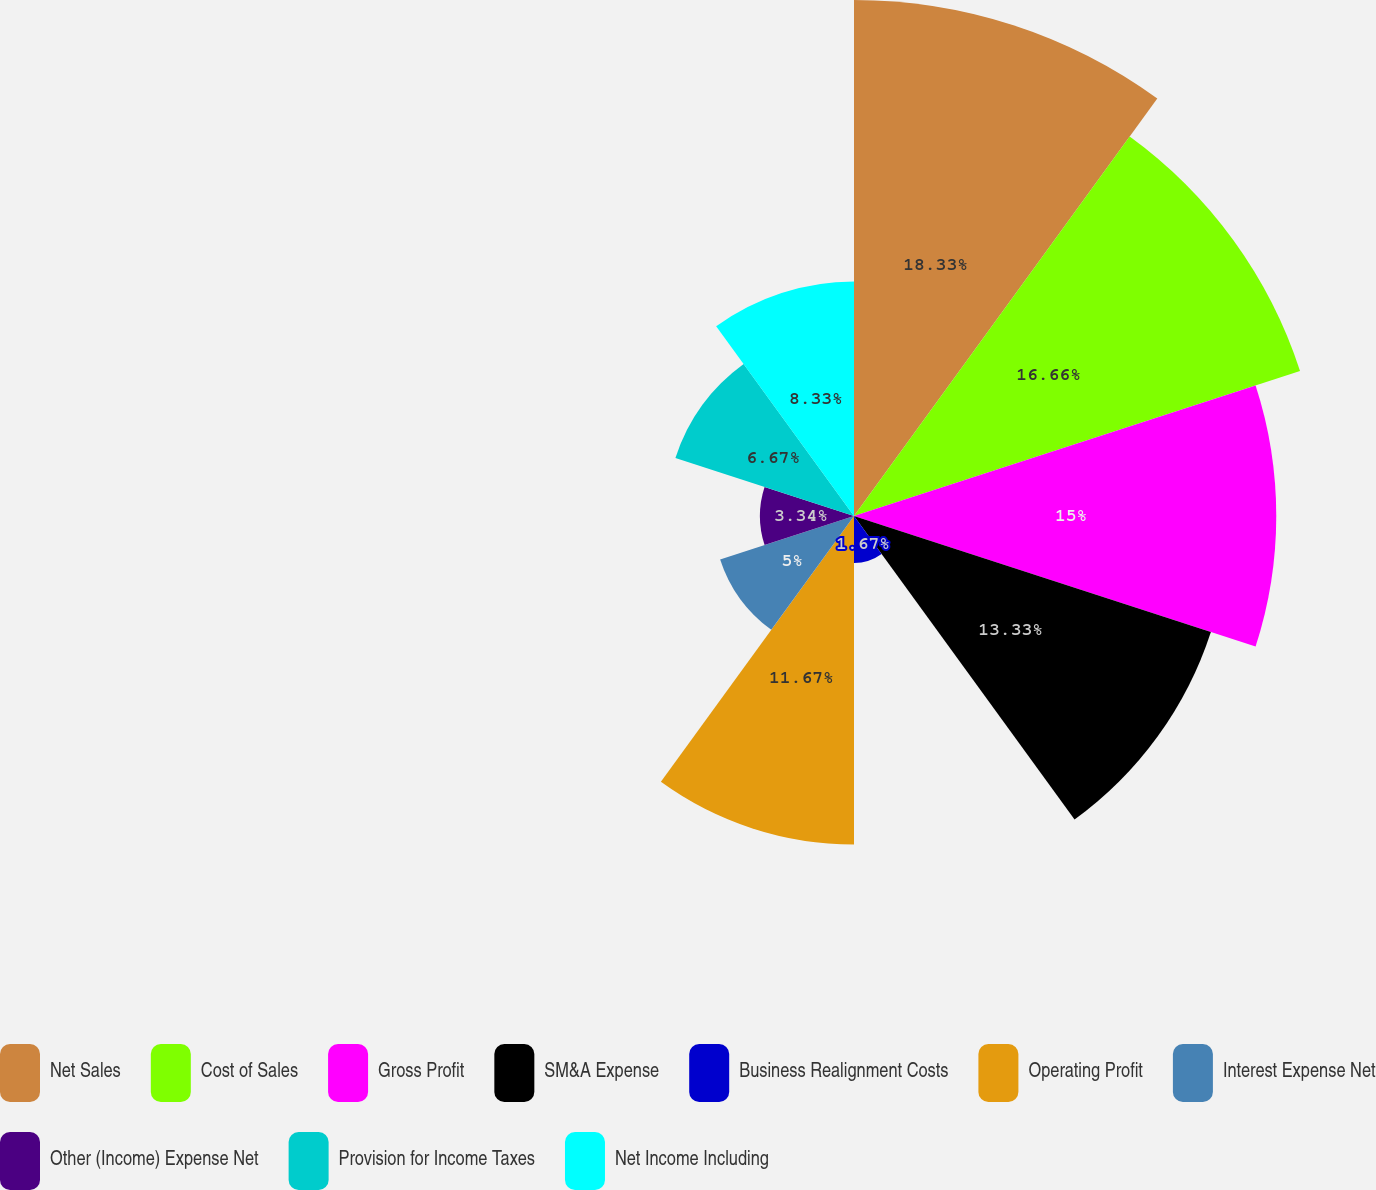<chart> <loc_0><loc_0><loc_500><loc_500><pie_chart><fcel>Net Sales<fcel>Cost of Sales<fcel>Gross Profit<fcel>SM&A Expense<fcel>Business Realignment Costs<fcel>Operating Profit<fcel>Interest Expense Net<fcel>Other (Income) Expense Net<fcel>Provision for Income Taxes<fcel>Net Income Including<nl><fcel>18.33%<fcel>16.66%<fcel>15.0%<fcel>13.33%<fcel>1.67%<fcel>11.67%<fcel>5.0%<fcel>3.34%<fcel>6.67%<fcel>8.33%<nl></chart> 